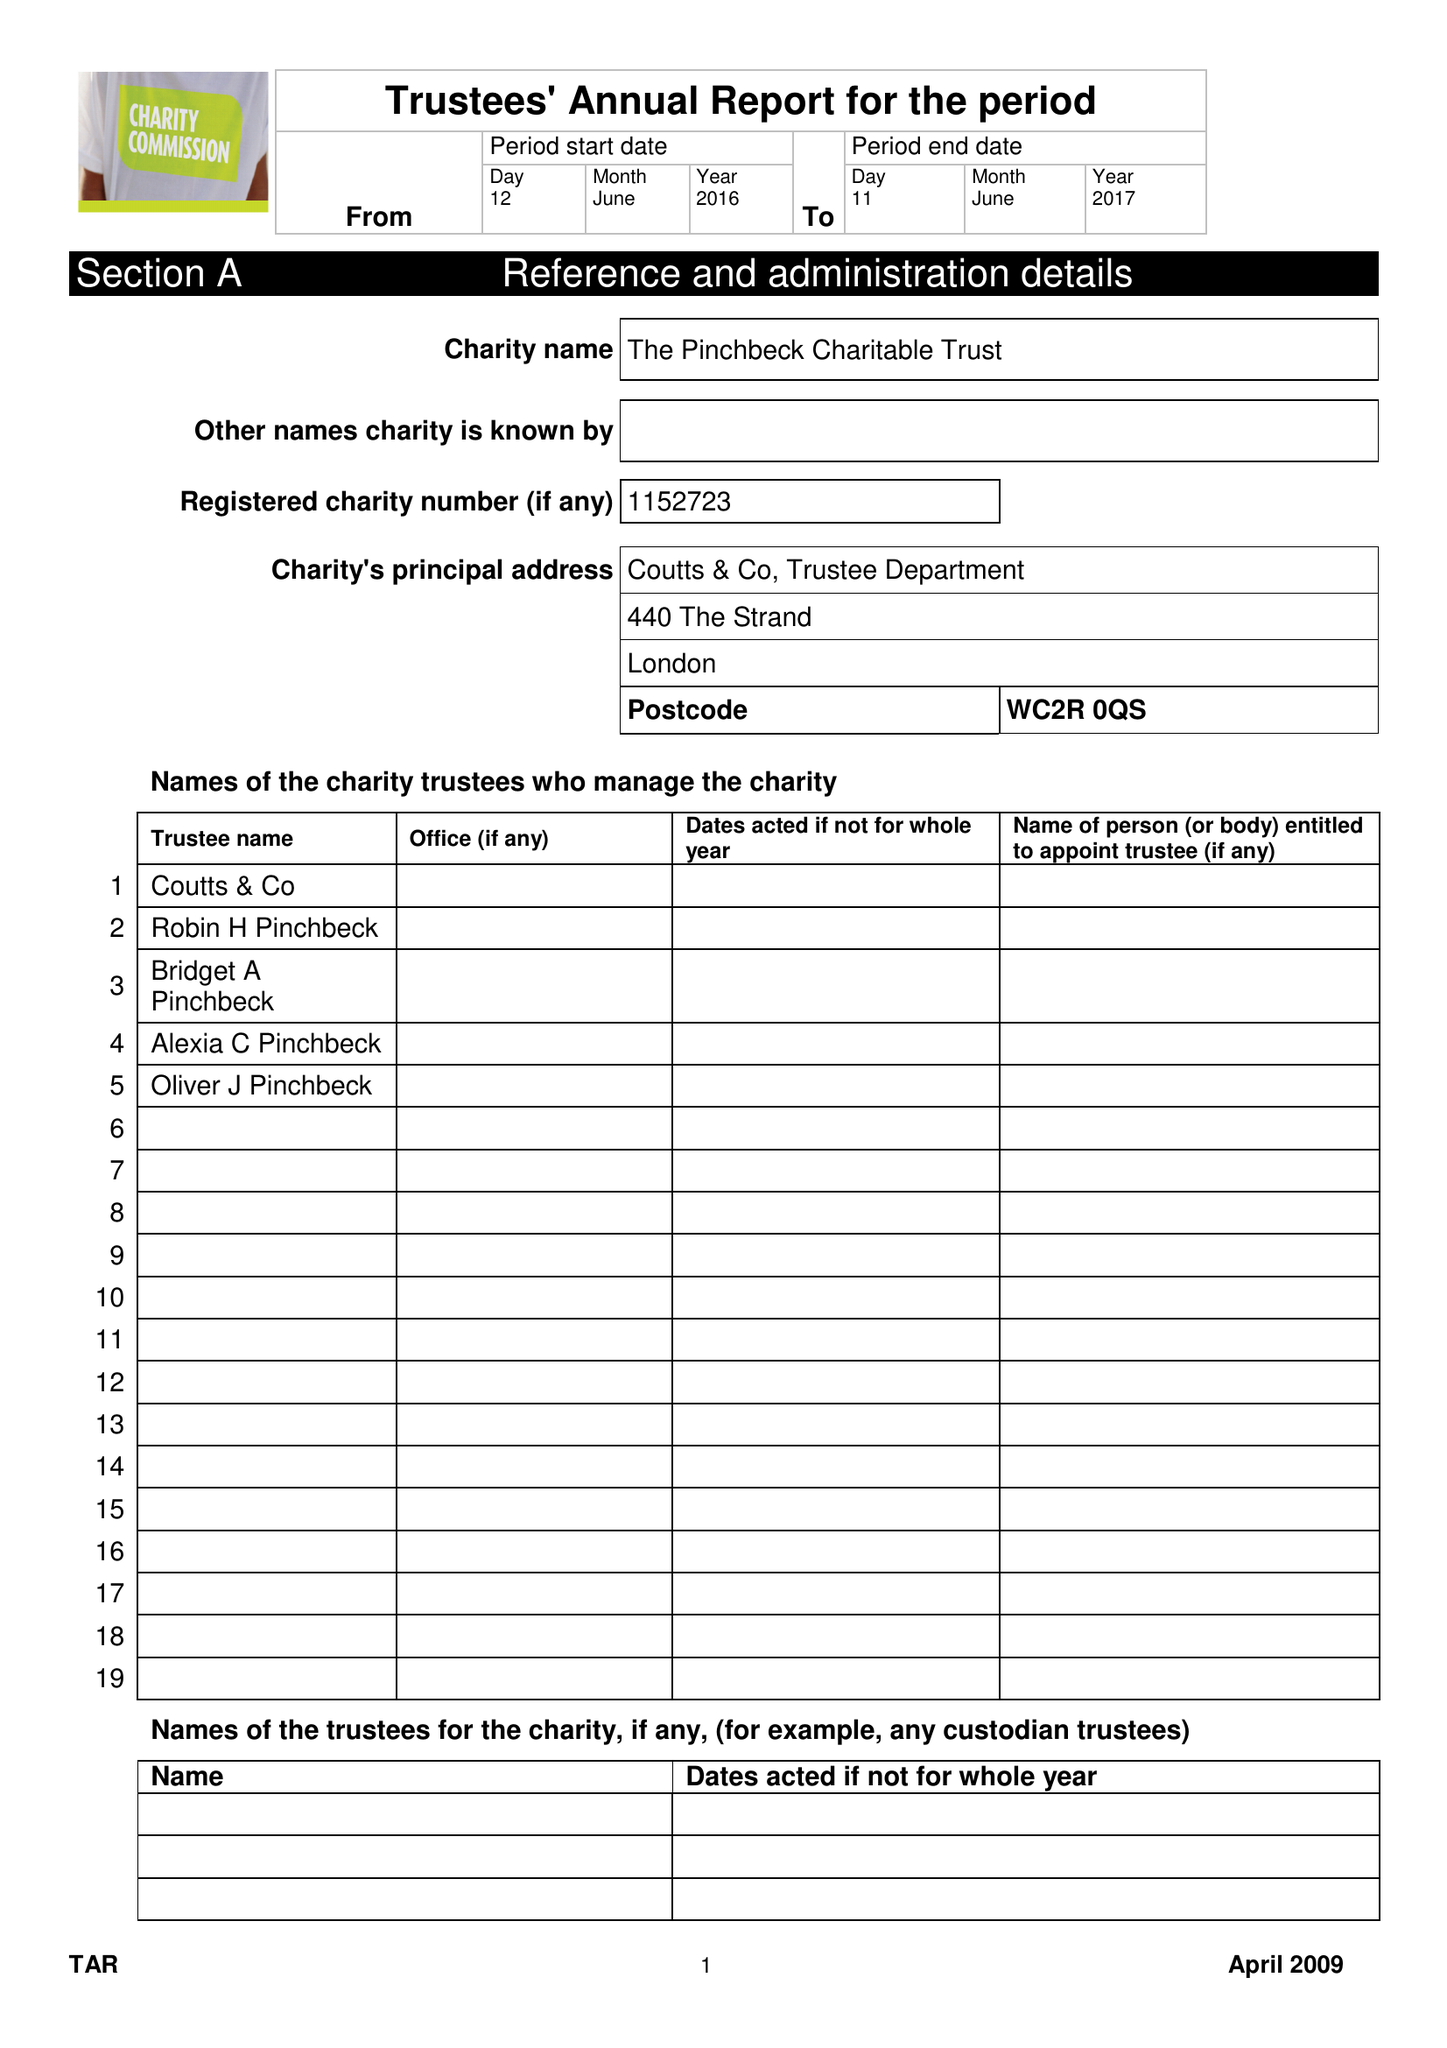What is the value for the income_annually_in_british_pounds?
Answer the question using a single word or phrase. 63635.00 